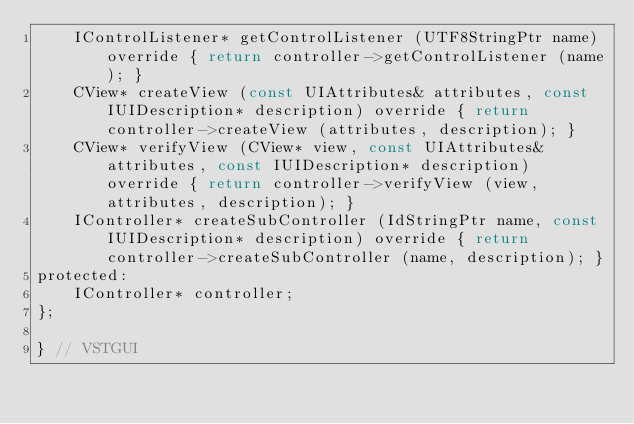<code> <loc_0><loc_0><loc_500><loc_500><_C_>	IControlListener* getControlListener (UTF8StringPtr name) override { return controller->getControlListener (name); }
	CView* createView (const UIAttributes& attributes, const IUIDescription* description) override { return controller->createView (attributes, description); }
	CView* verifyView (CView* view, const UIAttributes& attributes, const IUIDescription* description) override { return controller->verifyView (view, attributes, description); }
	IController* createSubController (IdStringPtr name, const IUIDescription* description) override { return controller->createSubController (name, description); }
protected:
	IController* controller;
};

} // VSTGUI
</code> 